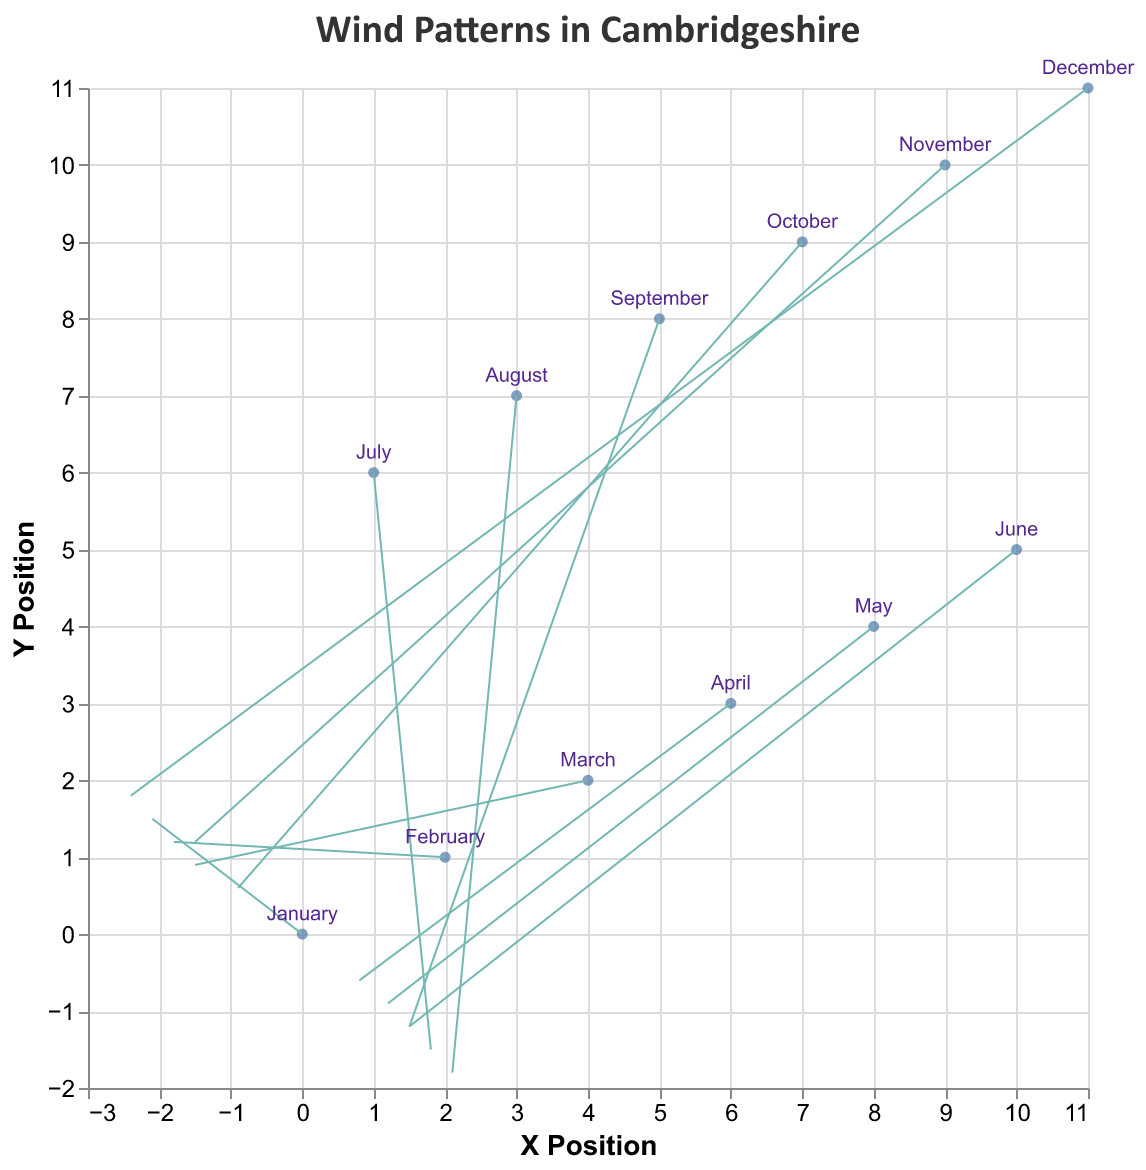what is the title of the figure? The title of the figure appears at the top and is labeled as "Wind Patterns in Cambridgeshire".
Answer: Wind Patterns in Cambridgeshire What months show wind patterns directed towards the northern hemisphere? For wind patterns directed towards the northern hemisphere, the v component should be positive. From the data, these months are January, February, March, October, November, and December.
Answer: January, February, March, October, November, December What are the u and v wind components for April? The data indicates that the u and v components for April are 0.8 and -0.6 respectively, shown by the tooltip or the data points.
Answer: 0.8, -0.6 In which month is the wind pattern moving southeast? A southeast direction would have positive u and negative v components. The month with these properties is August (u = 2.1, v = -1.8).
Answer: August How many data points are in the figure? Each month from January to December is represented as a data point in the figure. There are 12 data points in total.
Answer: 12 Which month has the greatest magnitude of the wind vector? The magnitude of the wind vector can be calculated as sqrt(u^2 + v^2). December has the vectors (u=-2.4, v=1.8), making its magnitude sqrt((2.4)^2 + (1.8)^2) = sqrt(5.76 + 3.24) = sqrt(9) = 3, which is highest among all months.
Answer: December How does the wind direction change between July and October? July has wind components (u=1.8, v=-1.5), indicating a general southwest direction, while October has (u=-0.9, v=0.6), indicating a northwest direction.
Answer: From southwest to northwest What is the average u component of the wind patterns from January to June? The u components from January to June are -2.1, -1.8, -1.5, 0.8, 1.2, and 1.5. The average is (-2.1 - 1.8 - 1.5 + 0.8 + 1.2 + 1.5)/6 = -1.2/6 = -0.2.
Answer: -0.2 Identify the months with negative u components. The u component is negative for the months January, February, March, October, November, and December.
Answer: January, February, March, October, November, December 